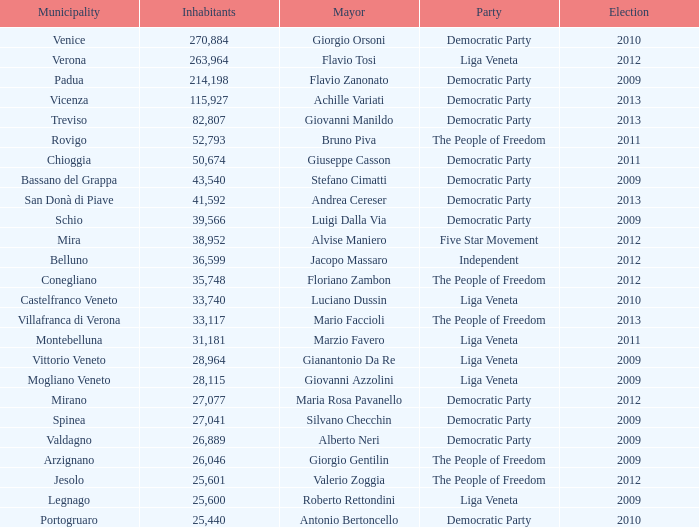How many elections had more than 36,599 inhabitants when Mayor was giovanni manildo? 1.0. 